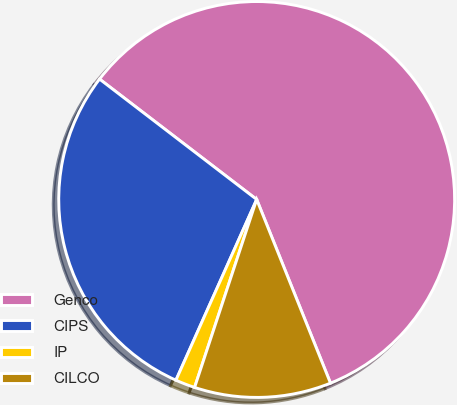Convert chart to OTSL. <chart><loc_0><loc_0><loc_500><loc_500><pie_chart><fcel>Genco<fcel>CIPS<fcel>IP<fcel>CILCO<nl><fcel>58.52%<fcel>28.72%<fcel>1.61%<fcel>11.16%<nl></chart> 